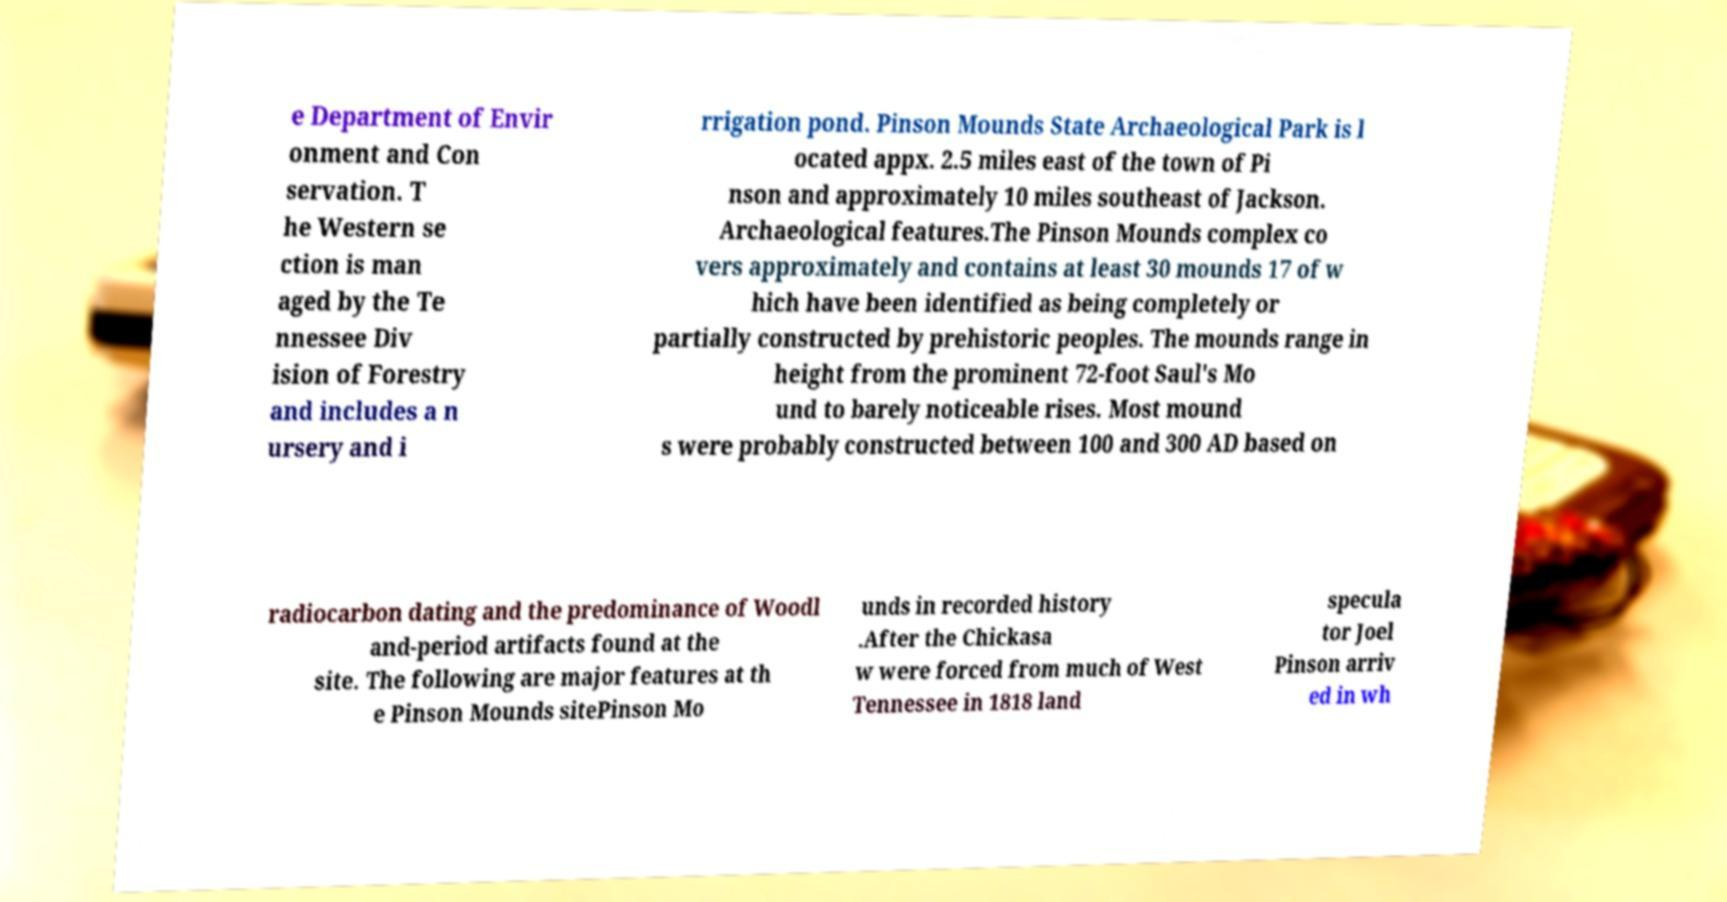Please read and relay the text visible in this image. What does it say? e Department of Envir onment and Con servation. T he Western se ction is man aged by the Te nnessee Div ision of Forestry and includes a n ursery and i rrigation pond. Pinson Mounds State Archaeological Park is l ocated appx. 2.5 miles east of the town of Pi nson and approximately 10 miles southeast of Jackson. Archaeological features.The Pinson Mounds complex co vers approximately and contains at least 30 mounds 17 of w hich have been identified as being completely or partially constructed by prehistoric peoples. The mounds range in height from the prominent 72-foot Saul's Mo und to barely noticeable rises. Most mound s were probably constructed between 100 and 300 AD based on radiocarbon dating and the predominance of Woodl and-period artifacts found at the site. The following are major features at th e Pinson Mounds sitePinson Mo unds in recorded history .After the Chickasa w were forced from much of West Tennessee in 1818 land specula tor Joel Pinson arriv ed in wh 